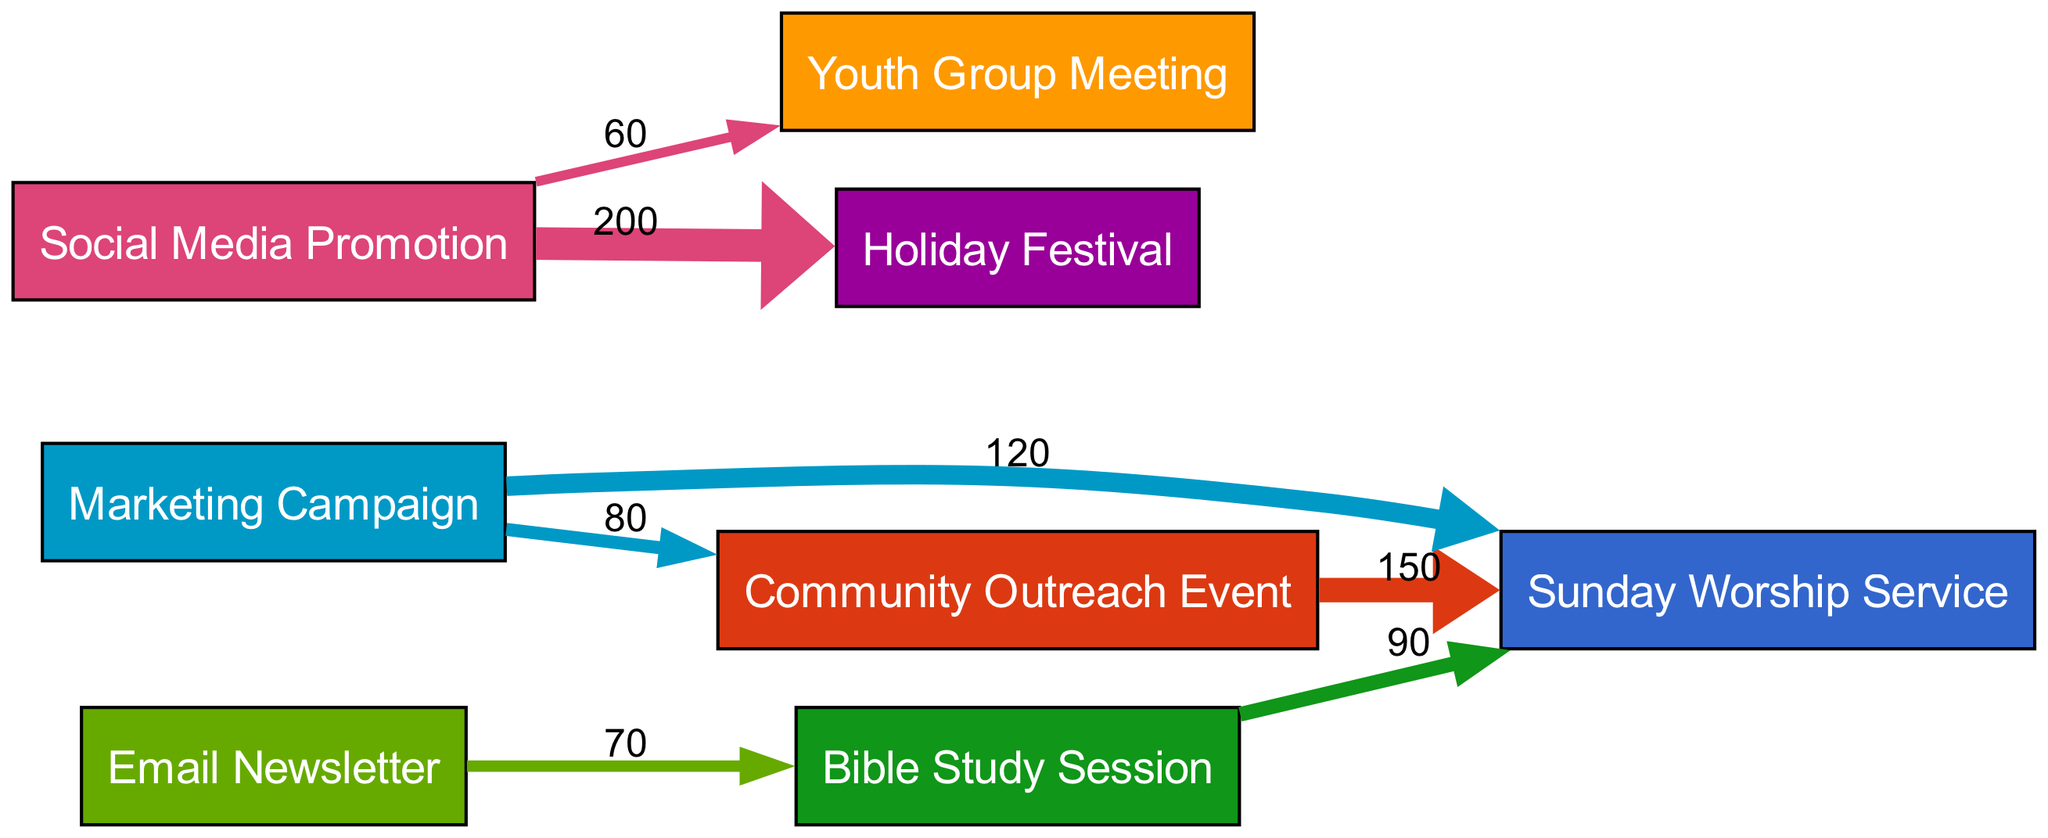What is the total number of events represented in the diagram? The diagram has one node for each event, specifically "Sunday Worship Service," "Community Outreach Event," "Youth Group Meeting," "Bible Study Session," and "Holiday Festival." This gives a total of 5 events.
Answer: 5 Which event received the highest participation from the Marketing Campaign? The Marketing Campaign links to "Sunday Worship Service" with a value of 120, which is higher than any other event it influences.
Answer: Sunday Worship Service How many sources contribute to the Sunday Worship Service participation? The Sunday Worship Service has links from "Marketing Campaign," "Community Outreach Event," and "Bible Study Session." This totals 3 distinct sources.
Answer: 3 What is the value of attendance influenced by Social Media Promotion for the Holiday Festival? From the diagram, the link from "Social Media Promotion" to "Holiday Festival" has a value of 200, indicating the attendance influenced by that promotional channel.
Answer: 200 Which event shows the strongest direct influence from the Community Outreach Event? The Community Outreach Event has a direct link to "Sunday Worship Service," with the highest flow value of 150 in that relationship.
Answer: Sunday Worship Service What percentage of the total attendance for the Youth Group Meeting comes from Social Media Promotion? The only link impacting Youth Group Meeting comes from Social Media Promotion, which has a value of 60. Thus, 100% of attendance for this event derives directly from this source.
Answer: 100% How many edges are there in total in this diagram? Counting the connections, the diagram features a total of 6 edges: from Marketing Campaign to two events, from Social Media Promotion to two events, as well as from the Community Outreach Event to Sunday Worship Service, and from Bible Study Session to Sunday Worship Service.
Answer: 6 What is the cumulative value of attendance influenced by the Marketing Campaign? Adding the values for the links from the Marketing Campaign, we have 120 (to Sunday Worship Service) + 80 (to Community Outreach Event) = 200 total.
Answer: 200 